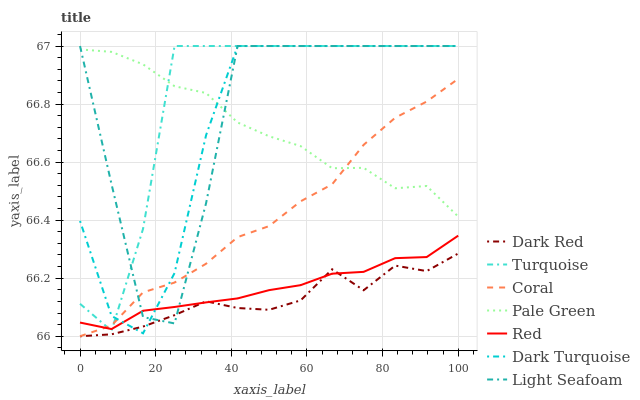Does Coral have the minimum area under the curve?
Answer yes or no. No. Does Coral have the maximum area under the curve?
Answer yes or no. No. Is Dark Red the smoothest?
Answer yes or no. No. Is Dark Red the roughest?
Answer yes or no. No. Does Pale Green have the lowest value?
Answer yes or no. No. Does Coral have the highest value?
Answer yes or no. No. Is Red less than Pale Green?
Answer yes or no. Yes. Is Turquoise greater than Dark Red?
Answer yes or no. Yes. Does Red intersect Pale Green?
Answer yes or no. No. 